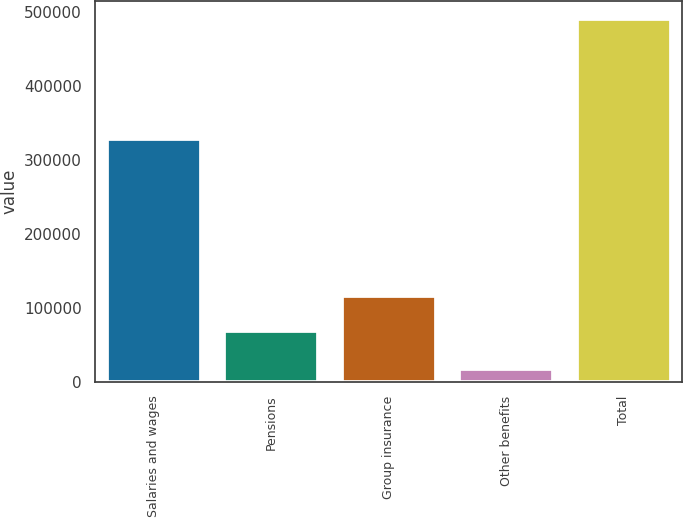<chart> <loc_0><loc_0><loc_500><loc_500><bar_chart><fcel>Salaries and wages<fcel>Pensions<fcel>Group insurance<fcel>Other benefits<fcel>Total<nl><fcel>327777<fcel>68885<fcel>116063<fcel>18054<fcel>489836<nl></chart> 